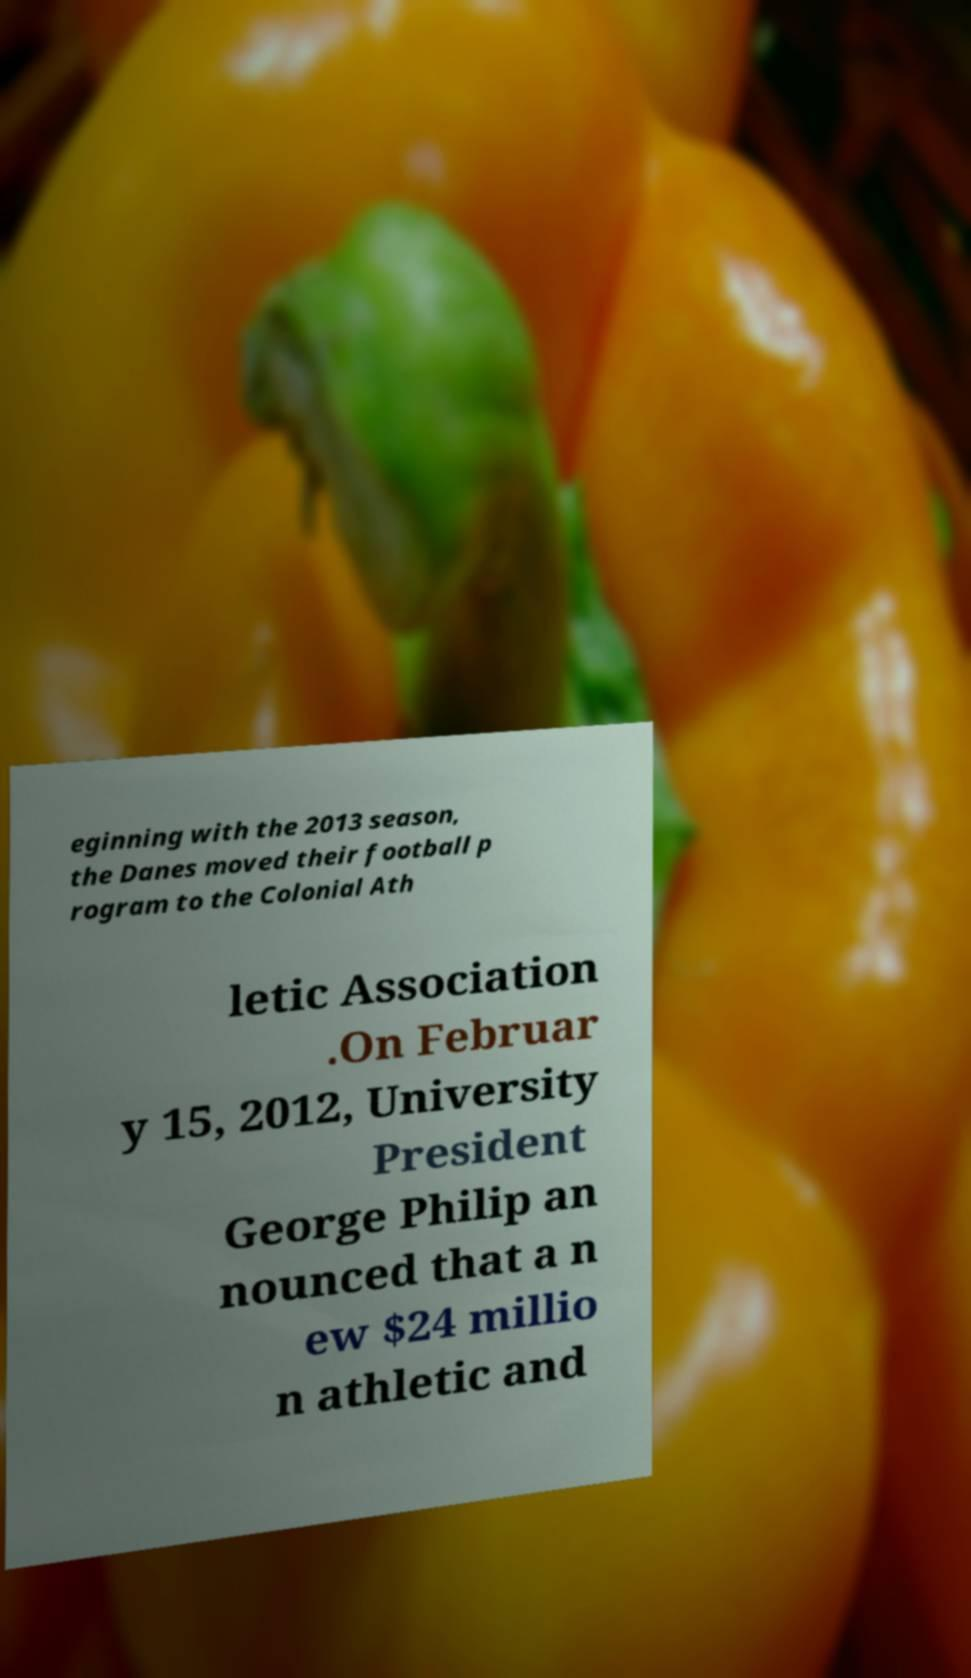Please identify and transcribe the text found in this image. eginning with the 2013 season, the Danes moved their football p rogram to the Colonial Ath letic Association .On Februar y 15, 2012, University President George Philip an nounced that a n ew $24 millio n athletic and 